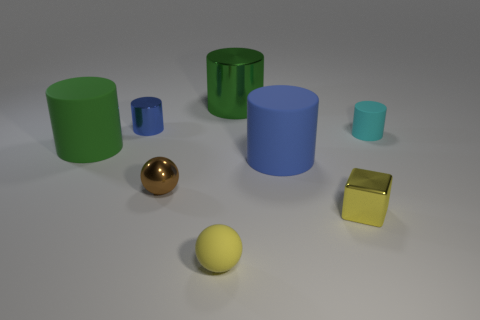Subtract all green cylinders. How many cylinders are left? 3 Subtract all big metallic cylinders. How many cylinders are left? 4 Subtract all cylinders. How many objects are left? 3 Subtract all purple cylinders. Subtract all brown cubes. How many cylinders are left? 5 Subtract all gray blocks. How many yellow spheres are left? 1 Subtract all green matte spheres. Subtract all metallic spheres. How many objects are left? 7 Add 3 blue cylinders. How many blue cylinders are left? 5 Add 7 cyan balls. How many cyan balls exist? 7 Add 2 small yellow things. How many objects exist? 10 Subtract 0 gray blocks. How many objects are left? 8 